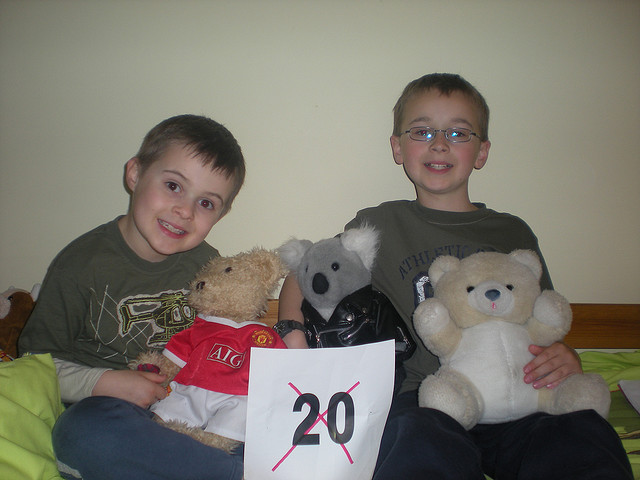Identify and read out the text in this image. ATHLETIC 20 AIG 